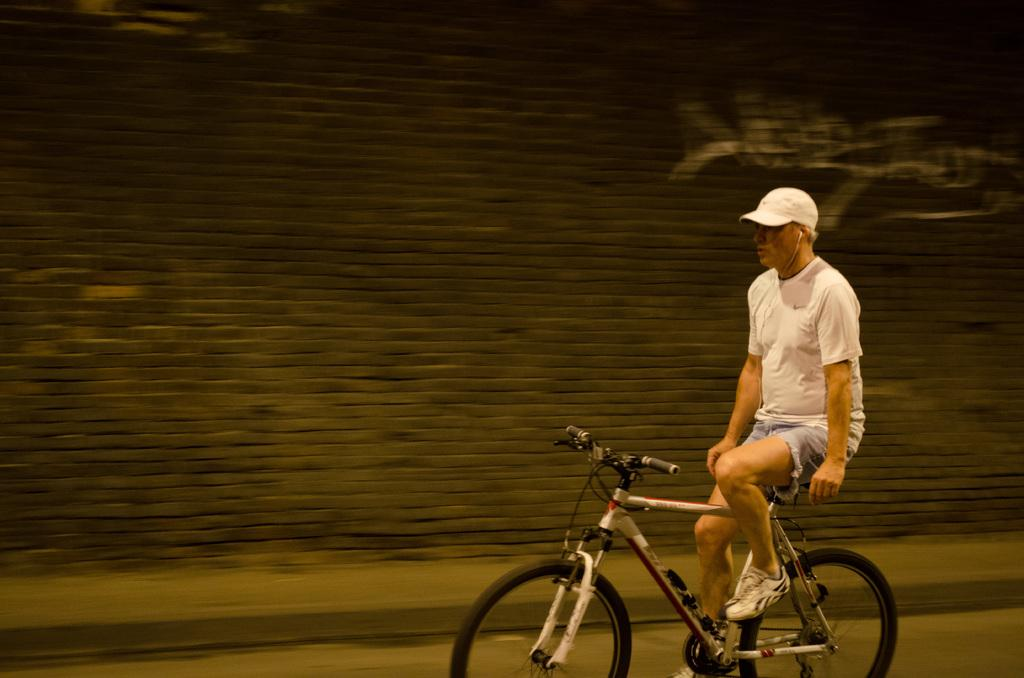Who is in the image? There is a man in the image. What is the man wearing? The man is wearing a white t-shirt. What is the man doing in the image? The man is riding a bicycle. Where is the bicycle located? The bicycle is on the road. What can be seen behind the man? There is a wall behind the man. What type of chain is the robin holding in the image? There is no robin or chain present in the image. How does the wind affect the man's hair in the image? The image does not show the man's hair being affected by the wind, so we cannot determine its effect. 